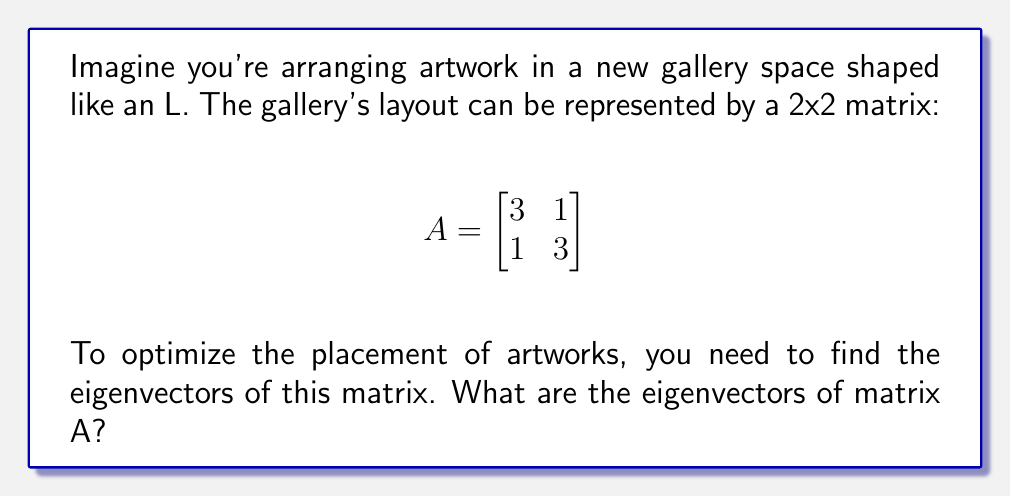Provide a solution to this math problem. To find the eigenvectors, we'll follow these steps:

1) First, we need to find the eigenvalues by solving the characteristic equation:
   $$det(A - \lambda I) = 0$$

2) Expand the determinant:
   $$\begin{vmatrix}
   3-\lambda & 1 \\
   1 & 3-\lambda
   \end{vmatrix} = 0$$

3) Solve the resulting quadratic equation:
   $$(3-\lambda)^2 - 1 = 0$$
   $$\lambda^2 - 6\lambda + 8 = 0$$

4) The solutions are $\lambda_1 = 4$ and $\lambda_2 = 2$

5) For each eigenvalue, we solve $(A - \lambda I)v = 0$ to find the corresponding eigenvector:

   For $\lambda_1 = 4$:
   $$\begin{bmatrix}
   -1 & 1 \\
   1 & -1
   \end{bmatrix}\begin{bmatrix}
   x \\
   y
   \end{bmatrix} = \begin{bmatrix}
   0 \\
   0
   \end{bmatrix}$$

   This gives us $x = y$. We can choose $v_1 = \begin{bmatrix} 1 \\ 1 \end{bmatrix}$

   For $\lambda_2 = 2$:
   $$\begin{bmatrix}
   1 & 1 \\
   1 & 1
   \end{bmatrix}\begin{bmatrix}
   x \\
   y
   \end{bmatrix} = \begin{bmatrix}
   0 \\
   0
   \end{bmatrix}$$

   This gives us $x = -y$. We can choose $v_2 = \begin{bmatrix} 1 \\ -1 \end{bmatrix}$
Answer: $v_1 = \begin{bmatrix} 1 \\ 1 \end{bmatrix}$, $v_2 = \begin{bmatrix} 1 \\ -1 \end{bmatrix}$ 